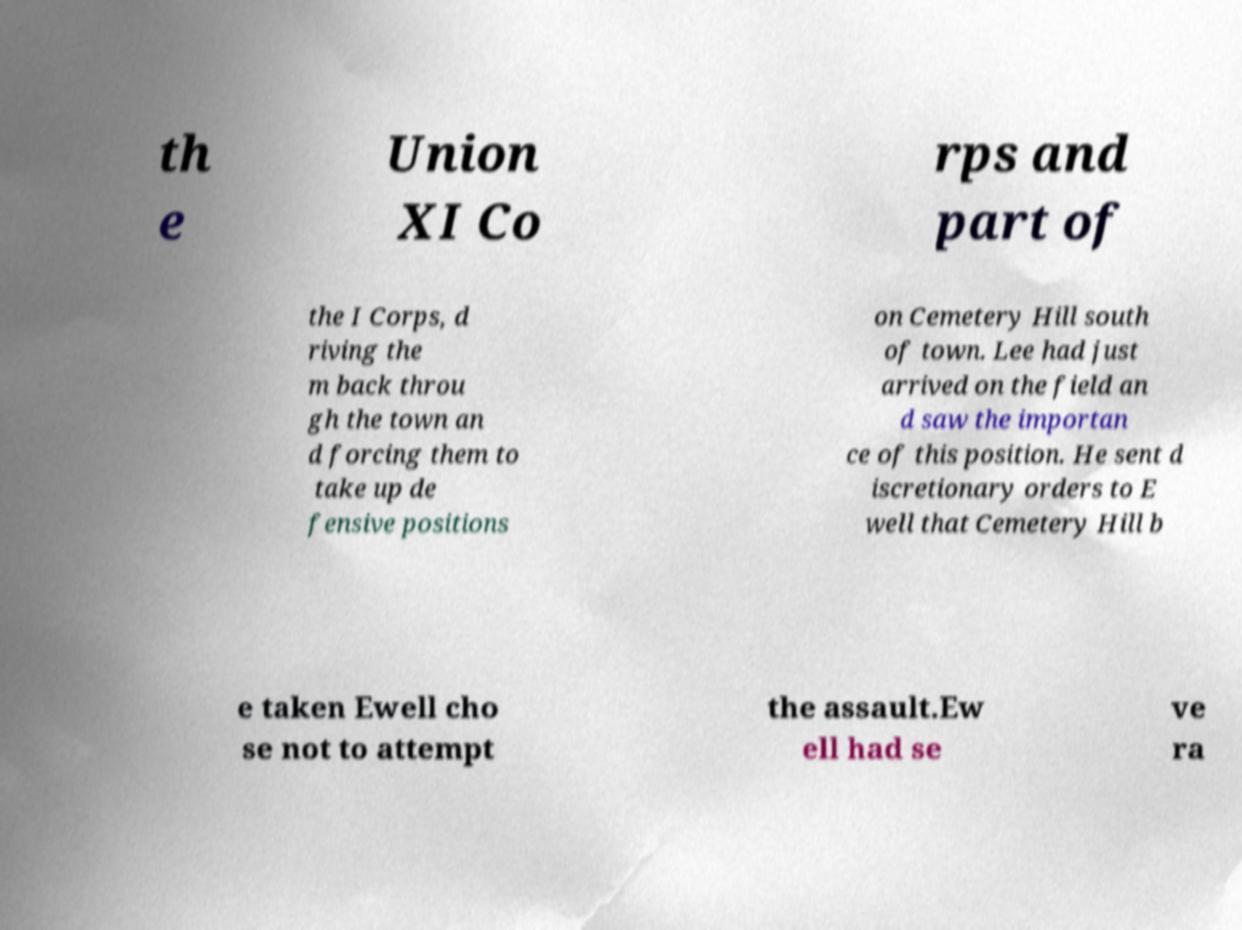Please read and relay the text visible in this image. What does it say? th e Union XI Co rps and part of the I Corps, d riving the m back throu gh the town an d forcing them to take up de fensive positions on Cemetery Hill south of town. Lee had just arrived on the field an d saw the importan ce of this position. He sent d iscretionary orders to E well that Cemetery Hill b e taken Ewell cho se not to attempt the assault.Ew ell had se ve ra 